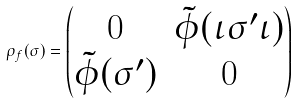<formula> <loc_0><loc_0><loc_500><loc_500>\rho _ { f } ( \sigma ) = \begin{pmatrix} 0 & \tilde { \phi } ( \iota \sigma ^ { \prime } \iota ) \\ \tilde { \phi } ( \sigma ^ { \prime } ) & 0 \end{pmatrix}</formula> 